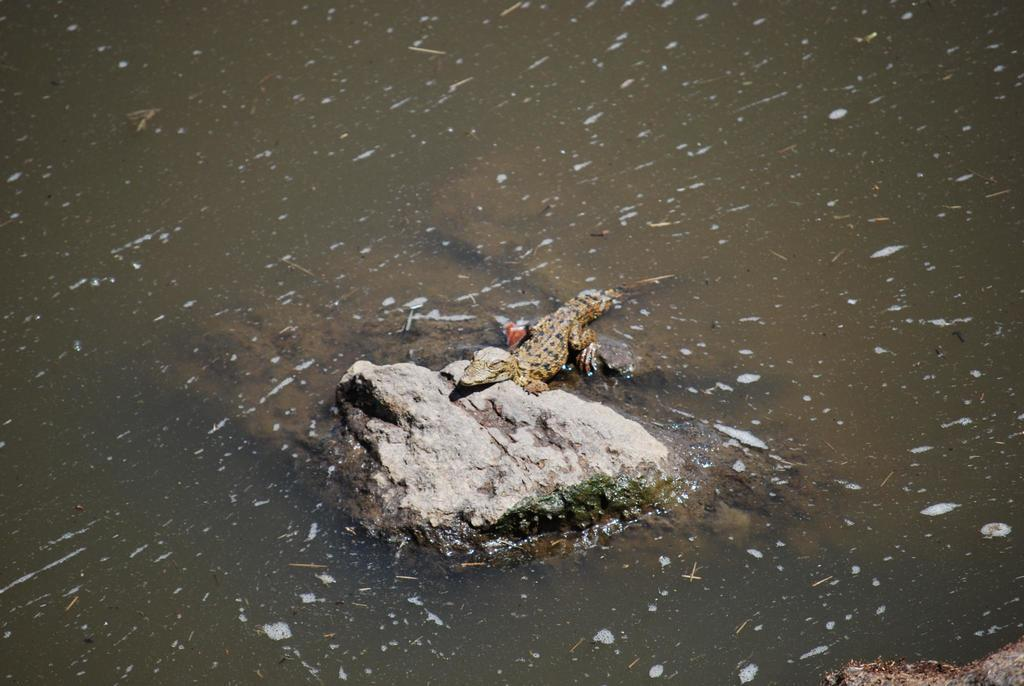What animal is the main subject of the image? There is a crocodile in the image. What is the crocodile resting on? The crocodile is on a stone. What can be seen in the background of the image? There is water visible in the image. What is the color of the crocodile? The crocodile is brown in color. How many cherries are on the crocodile's back in the image? There are no cherries present in the image, and therefore none can be found on the crocodile's back. 